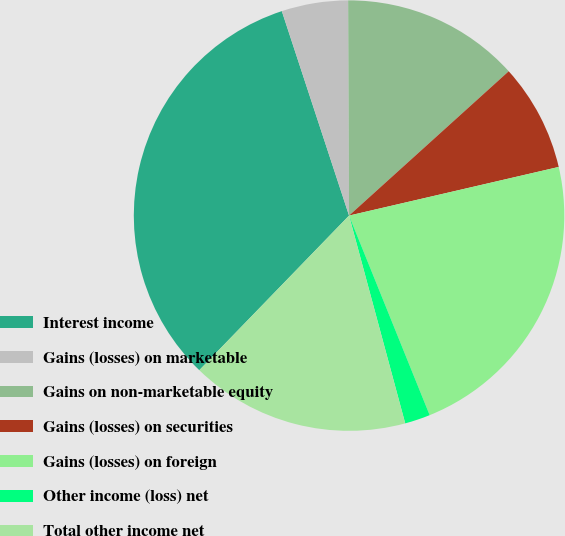Convert chart to OTSL. <chart><loc_0><loc_0><loc_500><loc_500><pie_chart><fcel>Interest income<fcel>Gains (losses) on marketable<fcel>Gains on non-marketable equity<fcel>Gains (losses) on securities<fcel>Gains (losses) on foreign<fcel>Other income (loss) net<fcel>Total other income net<nl><fcel>32.7%<fcel>4.99%<fcel>13.37%<fcel>8.07%<fcel>22.52%<fcel>1.91%<fcel>16.45%<nl></chart> 